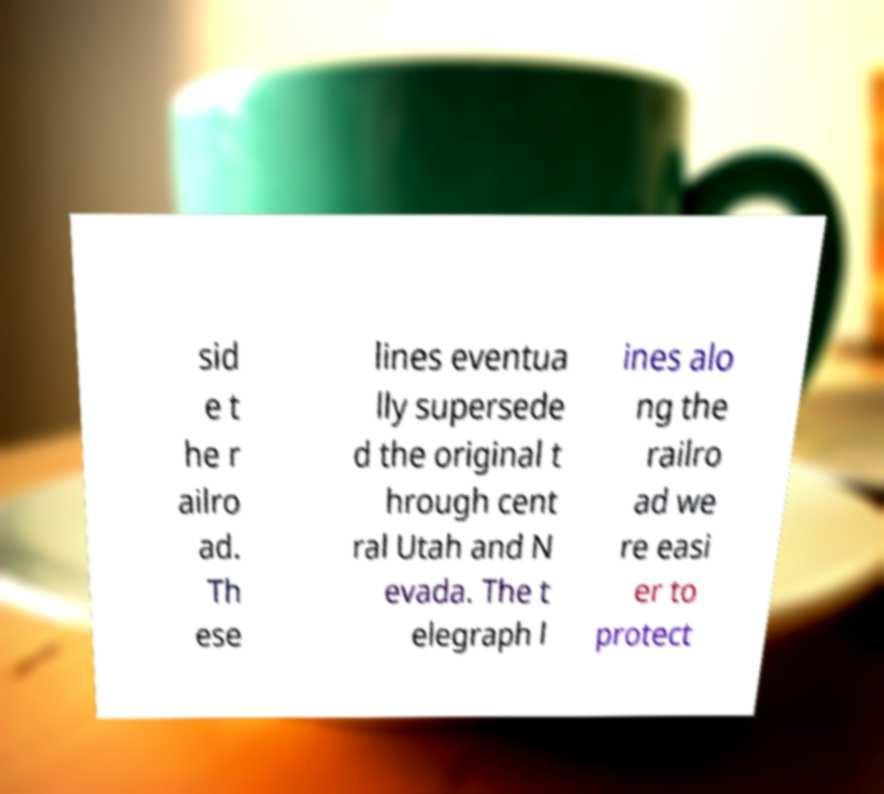Please identify and transcribe the text found in this image. sid e t he r ailro ad. Th ese lines eventua lly supersede d the original t hrough cent ral Utah and N evada. The t elegraph l ines alo ng the railro ad we re easi er to protect 